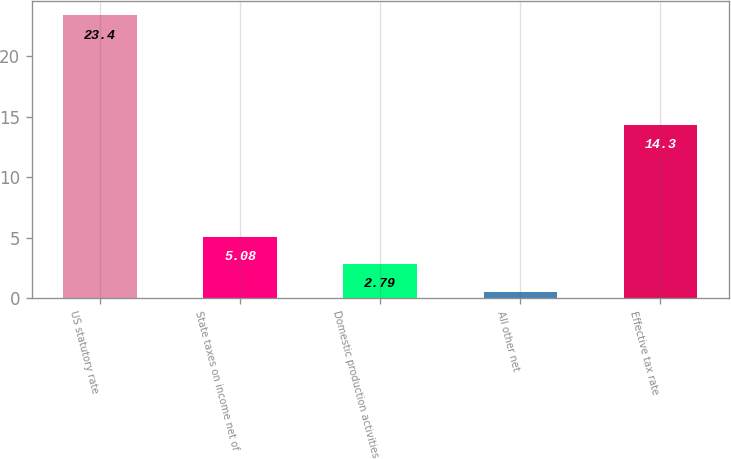<chart> <loc_0><loc_0><loc_500><loc_500><bar_chart><fcel>US statutory rate<fcel>State taxes on income net of<fcel>Domestic production activities<fcel>All other net<fcel>Effective tax rate<nl><fcel>23.4<fcel>5.08<fcel>2.79<fcel>0.5<fcel>14.3<nl></chart> 